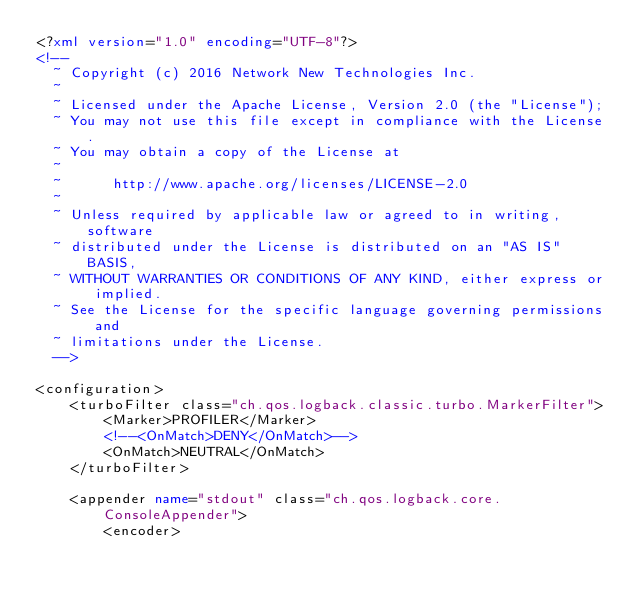Convert code to text. <code><loc_0><loc_0><loc_500><loc_500><_XML_><?xml version="1.0" encoding="UTF-8"?>
<!--
  ~ Copyright (c) 2016 Network New Technologies Inc.
  ~
  ~ Licensed under the Apache License, Version 2.0 (the "License");
  ~ You may not use this file except in compliance with the License.
  ~ You may obtain a copy of the License at
  ~
  ~      http://www.apache.org/licenses/LICENSE-2.0
  ~
  ~ Unless required by applicable law or agreed to in writing, software
  ~ distributed under the License is distributed on an "AS IS" BASIS,
  ~ WITHOUT WARRANTIES OR CONDITIONS OF ANY KIND, either express or implied.
  ~ See the License for the specific language governing permissions and
  ~ limitations under the License.
  -->

<configuration>
    <turboFilter class="ch.qos.logback.classic.turbo.MarkerFilter">
        <Marker>PROFILER</Marker>
        <!--<OnMatch>DENY</OnMatch>-->
        <OnMatch>NEUTRAL</OnMatch>
    </turboFilter>

    <appender name="stdout" class="ch.qos.logback.core.ConsoleAppender">
        <encoder></code> 